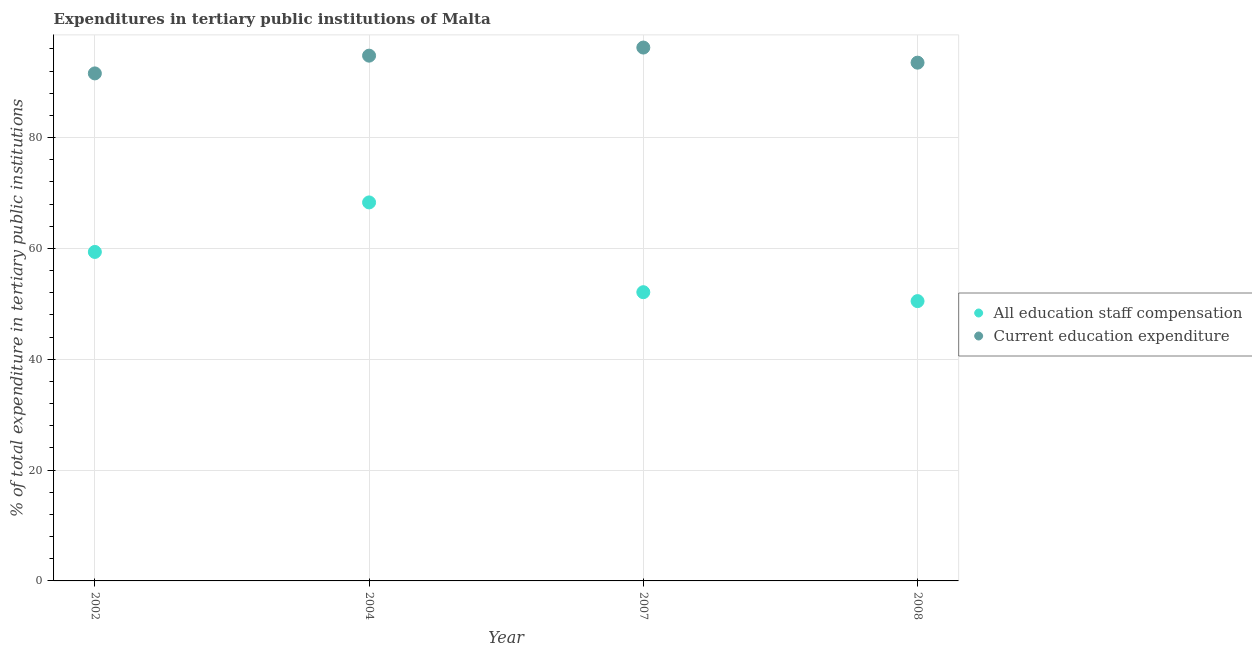Is the number of dotlines equal to the number of legend labels?
Your answer should be compact. Yes. What is the expenditure in staff compensation in 2004?
Give a very brief answer. 68.29. Across all years, what is the maximum expenditure in staff compensation?
Provide a succinct answer. 68.29. Across all years, what is the minimum expenditure in education?
Offer a terse response. 91.57. In which year was the expenditure in education minimum?
Ensure brevity in your answer.  2002. What is the total expenditure in staff compensation in the graph?
Provide a succinct answer. 230.22. What is the difference between the expenditure in education in 2002 and that in 2004?
Provide a succinct answer. -3.2. What is the difference between the expenditure in staff compensation in 2004 and the expenditure in education in 2008?
Your answer should be very brief. -25.21. What is the average expenditure in staff compensation per year?
Your answer should be very brief. 57.56. In the year 2008, what is the difference between the expenditure in education and expenditure in staff compensation?
Make the answer very short. 43.02. In how many years, is the expenditure in staff compensation greater than 32 %?
Offer a very short reply. 4. What is the ratio of the expenditure in education in 2002 to that in 2008?
Give a very brief answer. 0.98. Is the difference between the expenditure in staff compensation in 2004 and 2007 greater than the difference between the expenditure in education in 2004 and 2007?
Keep it short and to the point. Yes. What is the difference between the highest and the second highest expenditure in staff compensation?
Your answer should be compact. 8.93. What is the difference between the highest and the lowest expenditure in staff compensation?
Provide a succinct answer. 17.81. In how many years, is the expenditure in education greater than the average expenditure in education taken over all years?
Keep it short and to the point. 2. Is the sum of the expenditure in staff compensation in 2002 and 2008 greater than the maximum expenditure in education across all years?
Give a very brief answer. Yes. Is the expenditure in staff compensation strictly greater than the expenditure in education over the years?
Provide a short and direct response. No. What is the difference between two consecutive major ticks on the Y-axis?
Keep it short and to the point. 20. Does the graph contain any zero values?
Your response must be concise. No. Does the graph contain grids?
Give a very brief answer. Yes. How many legend labels are there?
Offer a terse response. 2. How are the legend labels stacked?
Offer a terse response. Vertical. What is the title of the graph?
Keep it short and to the point. Expenditures in tertiary public institutions of Malta. What is the label or title of the X-axis?
Your answer should be compact. Year. What is the label or title of the Y-axis?
Your response must be concise. % of total expenditure in tertiary public institutions. What is the % of total expenditure in tertiary public institutions of All education staff compensation in 2002?
Offer a very short reply. 59.36. What is the % of total expenditure in tertiary public institutions in Current education expenditure in 2002?
Make the answer very short. 91.57. What is the % of total expenditure in tertiary public institutions of All education staff compensation in 2004?
Provide a short and direct response. 68.29. What is the % of total expenditure in tertiary public institutions in Current education expenditure in 2004?
Keep it short and to the point. 94.77. What is the % of total expenditure in tertiary public institutions in All education staff compensation in 2007?
Your answer should be very brief. 52.09. What is the % of total expenditure in tertiary public institutions of Current education expenditure in 2007?
Offer a terse response. 96.23. What is the % of total expenditure in tertiary public institutions of All education staff compensation in 2008?
Keep it short and to the point. 50.48. What is the % of total expenditure in tertiary public institutions in Current education expenditure in 2008?
Keep it short and to the point. 93.5. Across all years, what is the maximum % of total expenditure in tertiary public institutions in All education staff compensation?
Your answer should be compact. 68.29. Across all years, what is the maximum % of total expenditure in tertiary public institutions of Current education expenditure?
Provide a short and direct response. 96.23. Across all years, what is the minimum % of total expenditure in tertiary public institutions of All education staff compensation?
Give a very brief answer. 50.48. Across all years, what is the minimum % of total expenditure in tertiary public institutions of Current education expenditure?
Your answer should be very brief. 91.57. What is the total % of total expenditure in tertiary public institutions of All education staff compensation in the graph?
Give a very brief answer. 230.22. What is the total % of total expenditure in tertiary public institutions in Current education expenditure in the graph?
Your answer should be very brief. 376.07. What is the difference between the % of total expenditure in tertiary public institutions in All education staff compensation in 2002 and that in 2004?
Offer a very short reply. -8.93. What is the difference between the % of total expenditure in tertiary public institutions of Current education expenditure in 2002 and that in 2004?
Your answer should be compact. -3.2. What is the difference between the % of total expenditure in tertiary public institutions in All education staff compensation in 2002 and that in 2007?
Provide a short and direct response. 7.26. What is the difference between the % of total expenditure in tertiary public institutions in Current education expenditure in 2002 and that in 2007?
Your response must be concise. -4.66. What is the difference between the % of total expenditure in tertiary public institutions of All education staff compensation in 2002 and that in 2008?
Your response must be concise. 8.87. What is the difference between the % of total expenditure in tertiary public institutions of Current education expenditure in 2002 and that in 2008?
Your response must be concise. -1.94. What is the difference between the % of total expenditure in tertiary public institutions of All education staff compensation in 2004 and that in 2007?
Make the answer very short. 16.2. What is the difference between the % of total expenditure in tertiary public institutions of Current education expenditure in 2004 and that in 2007?
Ensure brevity in your answer.  -1.46. What is the difference between the % of total expenditure in tertiary public institutions in All education staff compensation in 2004 and that in 2008?
Give a very brief answer. 17.81. What is the difference between the % of total expenditure in tertiary public institutions in Current education expenditure in 2004 and that in 2008?
Your answer should be very brief. 1.26. What is the difference between the % of total expenditure in tertiary public institutions of All education staff compensation in 2007 and that in 2008?
Provide a succinct answer. 1.61. What is the difference between the % of total expenditure in tertiary public institutions of Current education expenditure in 2007 and that in 2008?
Make the answer very short. 2.73. What is the difference between the % of total expenditure in tertiary public institutions in All education staff compensation in 2002 and the % of total expenditure in tertiary public institutions in Current education expenditure in 2004?
Keep it short and to the point. -35.41. What is the difference between the % of total expenditure in tertiary public institutions in All education staff compensation in 2002 and the % of total expenditure in tertiary public institutions in Current education expenditure in 2007?
Make the answer very short. -36.88. What is the difference between the % of total expenditure in tertiary public institutions in All education staff compensation in 2002 and the % of total expenditure in tertiary public institutions in Current education expenditure in 2008?
Ensure brevity in your answer.  -34.15. What is the difference between the % of total expenditure in tertiary public institutions in All education staff compensation in 2004 and the % of total expenditure in tertiary public institutions in Current education expenditure in 2007?
Make the answer very short. -27.94. What is the difference between the % of total expenditure in tertiary public institutions of All education staff compensation in 2004 and the % of total expenditure in tertiary public institutions of Current education expenditure in 2008?
Keep it short and to the point. -25.21. What is the difference between the % of total expenditure in tertiary public institutions in All education staff compensation in 2007 and the % of total expenditure in tertiary public institutions in Current education expenditure in 2008?
Provide a short and direct response. -41.41. What is the average % of total expenditure in tertiary public institutions of All education staff compensation per year?
Offer a terse response. 57.56. What is the average % of total expenditure in tertiary public institutions in Current education expenditure per year?
Your response must be concise. 94.02. In the year 2002, what is the difference between the % of total expenditure in tertiary public institutions of All education staff compensation and % of total expenditure in tertiary public institutions of Current education expenditure?
Ensure brevity in your answer.  -32.21. In the year 2004, what is the difference between the % of total expenditure in tertiary public institutions in All education staff compensation and % of total expenditure in tertiary public institutions in Current education expenditure?
Your answer should be very brief. -26.48. In the year 2007, what is the difference between the % of total expenditure in tertiary public institutions in All education staff compensation and % of total expenditure in tertiary public institutions in Current education expenditure?
Make the answer very short. -44.14. In the year 2008, what is the difference between the % of total expenditure in tertiary public institutions of All education staff compensation and % of total expenditure in tertiary public institutions of Current education expenditure?
Offer a very short reply. -43.02. What is the ratio of the % of total expenditure in tertiary public institutions in All education staff compensation in 2002 to that in 2004?
Offer a terse response. 0.87. What is the ratio of the % of total expenditure in tertiary public institutions of Current education expenditure in 2002 to that in 2004?
Your answer should be compact. 0.97. What is the ratio of the % of total expenditure in tertiary public institutions of All education staff compensation in 2002 to that in 2007?
Provide a succinct answer. 1.14. What is the ratio of the % of total expenditure in tertiary public institutions in Current education expenditure in 2002 to that in 2007?
Make the answer very short. 0.95. What is the ratio of the % of total expenditure in tertiary public institutions in All education staff compensation in 2002 to that in 2008?
Provide a short and direct response. 1.18. What is the ratio of the % of total expenditure in tertiary public institutions of Current education expenditure in 2002 to that in 2008?
Your answer should be compact. 0.98. What is the ratio of the % of total expenditure in tertiary public institutions of All education staff compensation in 2004 to that in 2007?
Offer a terse response. 1.31. What is the ratio of the % of total expenditure in tertiary public institutions of All education staff compensation in 2004 to that in 2008?
Ensure brevity in your answer.  1.35. What is the ratio of the % of total expenditure in tertiary public institutions in Current education expenditure in 2004 to that in 2008?
Provide a succinct answer. 1.01. What is the ratio of the % of total expenditure in tertiary public institutions of All education staff compensation in 2007 to that in 2008?
Keep it short and to the point. 1.03. What is the ratio of the % of total expenditure in tertiary public institutions of Current education expenditure in 2007 to that in 2008?
Ensure brevity in your answer.  1.03. What is the difference between the highest and the second highest % of total expenditure in tertiary public institutions in All education staff compensation?
Keep it short and to the point. 8.93. What is the difference between the highest and the second highest % of total expenditure in tertiary public institutions in Current education expenditure?
Keep it short and to the point. 1.46. What is the difference between the highest and the lowest % of total expenditure in tertiary public institutions of All education staff compensation?
Provide a short and direct response. 17.81. What is the difference between the highest and the lowest % of total expenditure in tertiary public institutions of Current education expenditure?
Your answer should be compact. 4.66. 